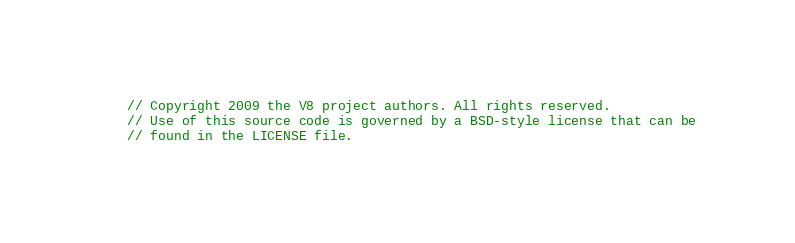Convert code to text. <code><loc_0><loc_0><loc_500><loc_500><_C++_>// Copyright 2009 the V8 project authors. All rights reserved.
// Use of this source code is governed by a BSD-style license that can be
// found in the LICENSE file.
</code> 